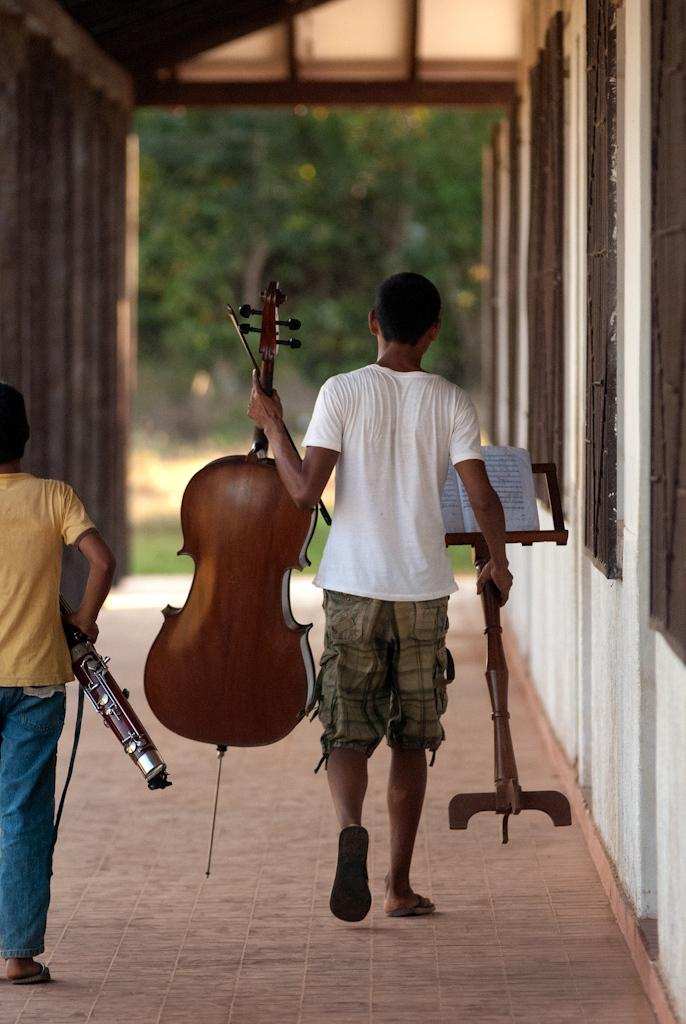How many people are in the image? There are two people in the image. What are the people doing in the image? The people are standing and holding musical instruments. What can be seen in the image besides the people? There is a stand, a tree, and a building in the image. Can you see any books on the stand in the image? There are no books visible on the stand in the image. Is there a river flowing through the image? There is no river present in the image. 